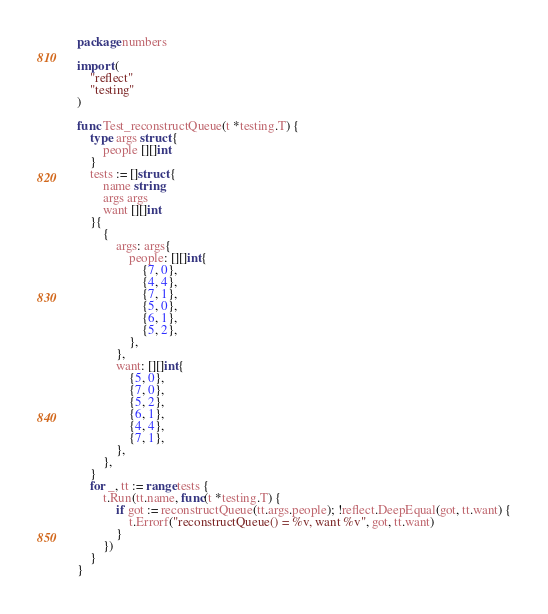<code> <loc_0><loc_0><loc_500><loc_500><_Go_>package numbers

import (
	"reflect"
	"testing"
)

func Test_reconstructQueue(t *testing.T) {
	type args struct {
		people [][]int
	}
	tests := []struct {
		name string
		args args
		want [][]int
	}{
		{
			args: args{
				people: [][]int{
					{7, 0},
					{4, 4},
					{7, 1},
					{5, 0},
					{6, 1},
					{5, 2},
				},
			},
			want: [][]int{
				{5, 0},
				{7, 0},
				{5, 2},
				{6, 1},
				{4, 4},
				{7, 1},
			},
		},
	}
	for _, tt := range tests {
		t.Run(tt.name, func(t *testing.T) {
			if got := reconstructQueue(tt.args.people); !reflect.DeepEqual(got, tt.want) {
				t.Errorf("reconstructQueue() = %v, want %v", got, tt.want)
			}
		})
	}
}
</code> 